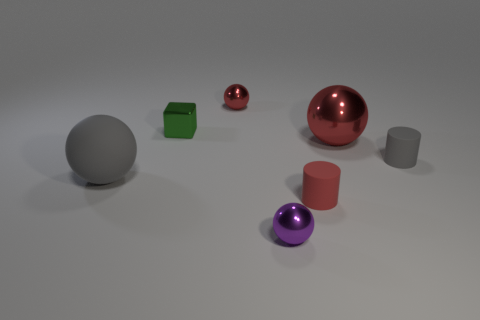There is a large thing that is the same material as the small cube; what shape is it?
Keep it short and to the point. Sphere. How many other objects are there of the same shape as the big gray thing?
Offer a very short reply. 3. Do the red metal object that is behind the shiny block and the large gray thing have the same size?
Offer a very short reply. No. Are there more tiny rubber objects on the right side of the tiny green block than red matte things?
Provide a succinct answer. Yes. There is a small green object that is behind the purple metal ball; what number of small green cubes are right of it?
Keep it short and to the point. 0. Are there fewer small things that are on the left side of the big red shiny thing than small red objects?
Give a very brief answer. No. There is a red metallic ball that is right of the metallic ball that is in front of the big gray sphere; is there a tiny object that is left of it?
Your answer should be compact. Yes. Does the small gray object have the same material as the big object behind the gray rubber ball?
Offer a very short reply. No. The small sphere that is behind the cylinder that is behind the red cylinder is what color?
Your response must be concise. Red. Are there any tiny objects of the same color as the large shiny ball?
Provide a short and direct response. Yes. 